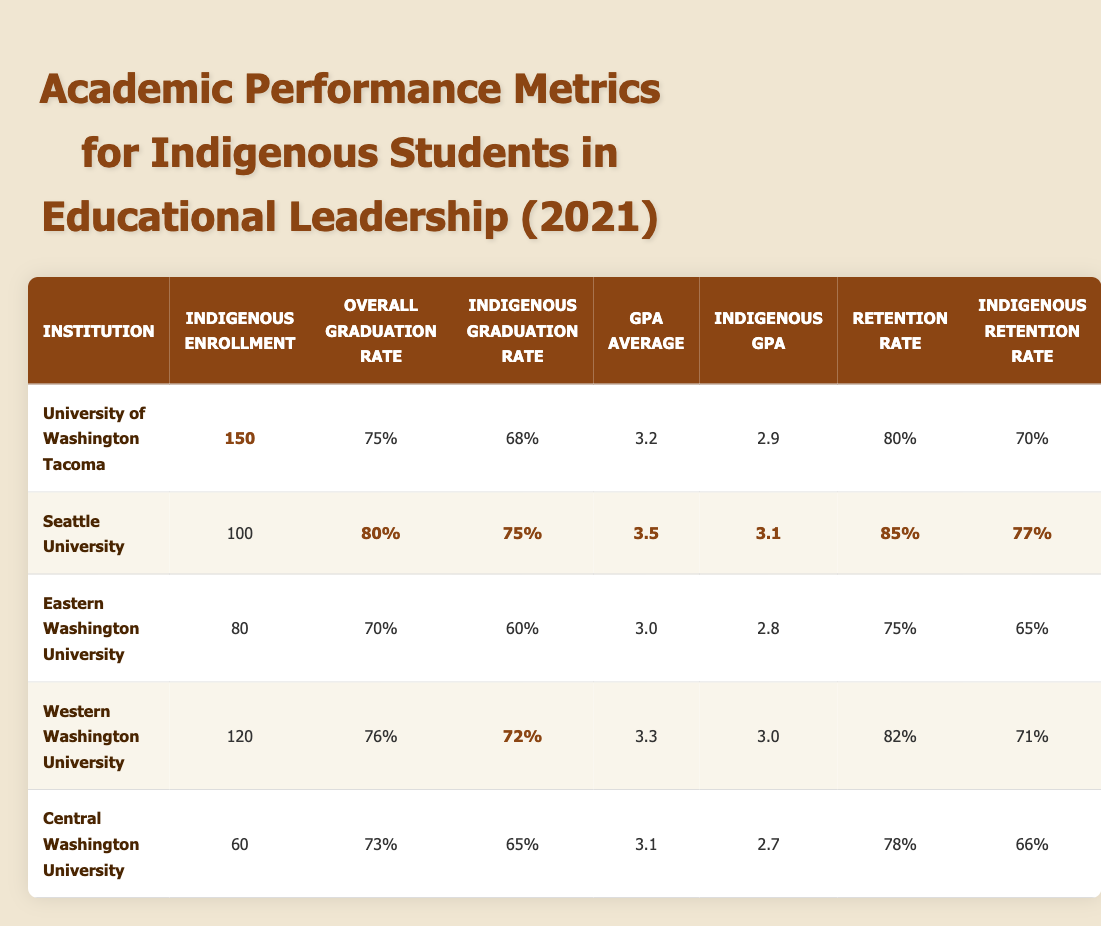What is the overall graduation rate for Seattle University? According to the table, the overall graduation rate for Seattle University is listed as 80%.
Answer: 80% What is the Indigenous enrollment for the University of Washington Tacoma? The Indigenous enrollment for the University of Washington Tacoma is highlighted in the table as 150.
Answer: 150 Which institution has the highest Indigenous retention rate? The highest Indigenous retention rate is found at Seattle University, which has a rate of 77%.
Answer: 77% What is the difference between the overall graduation rate and the Indigenous graduation rate at Eastern Washington University? The overall graduation rate at Eastern Washington University is 70%, and the Indigenous graduation rate is 60%. The difference is 70% - 60% = 10%.
Answer: 10% Is the Indigenous GPA at Western Washington University higher than that at Central Washington University? The Indigenous GPA at Western Washington University is 3.0, while at Central Washington University it is 2.7. Therefore, we can conclude that the Indigenous GPA at Western Washington University is higher.
Answer: Yes What is the average Indigenous GPA across all institutions listed in the table? To find the average Indigenous GPA, we first sum the Indigenous GPAs: 2.9 + 3.1 + 2.8 + 3.0 + 2.7 = 14.5. Then, we divide by the number of institutions (5) to get the average: 14.5 / 5 = 2.9.
Answer: 2.9 What percentage of Indigenous students graduate at the University of Washington Tacoma compared to the overall graduation rate? The Indigenous graduation rate at the University of Washington Tacoma is 68%, while the overall graduation rate is 75%. The Indigenous graduation rate is lower by 7%.
Answer: Yes, it is lower by 7% Which institution has both the highest overall graduation rate and retention rate? By inspecting the table, Seattle University has the highest overall graduation rate at 80% and the highest retention rate at 85%.
Answer: Seattle University What institution shows the largest gap between Indigenous graduation rate and overall graduation rate? To find the largest gap, we calculate the difference for each institution. For the University of Washington Tacoma, the gap is 75% - 68% = 7%. For Seattle University, it is 80% - 75% = 5%. For Eastern Washington University, it is 70% - 60% = 10%. For Western Washington University, it's 76% - 72% = 4%. For Central Washington University, it's 73% - 65% = 8%. The largest gap is 10% at Eastern Washington University.
Answer: Eastern Washington University 